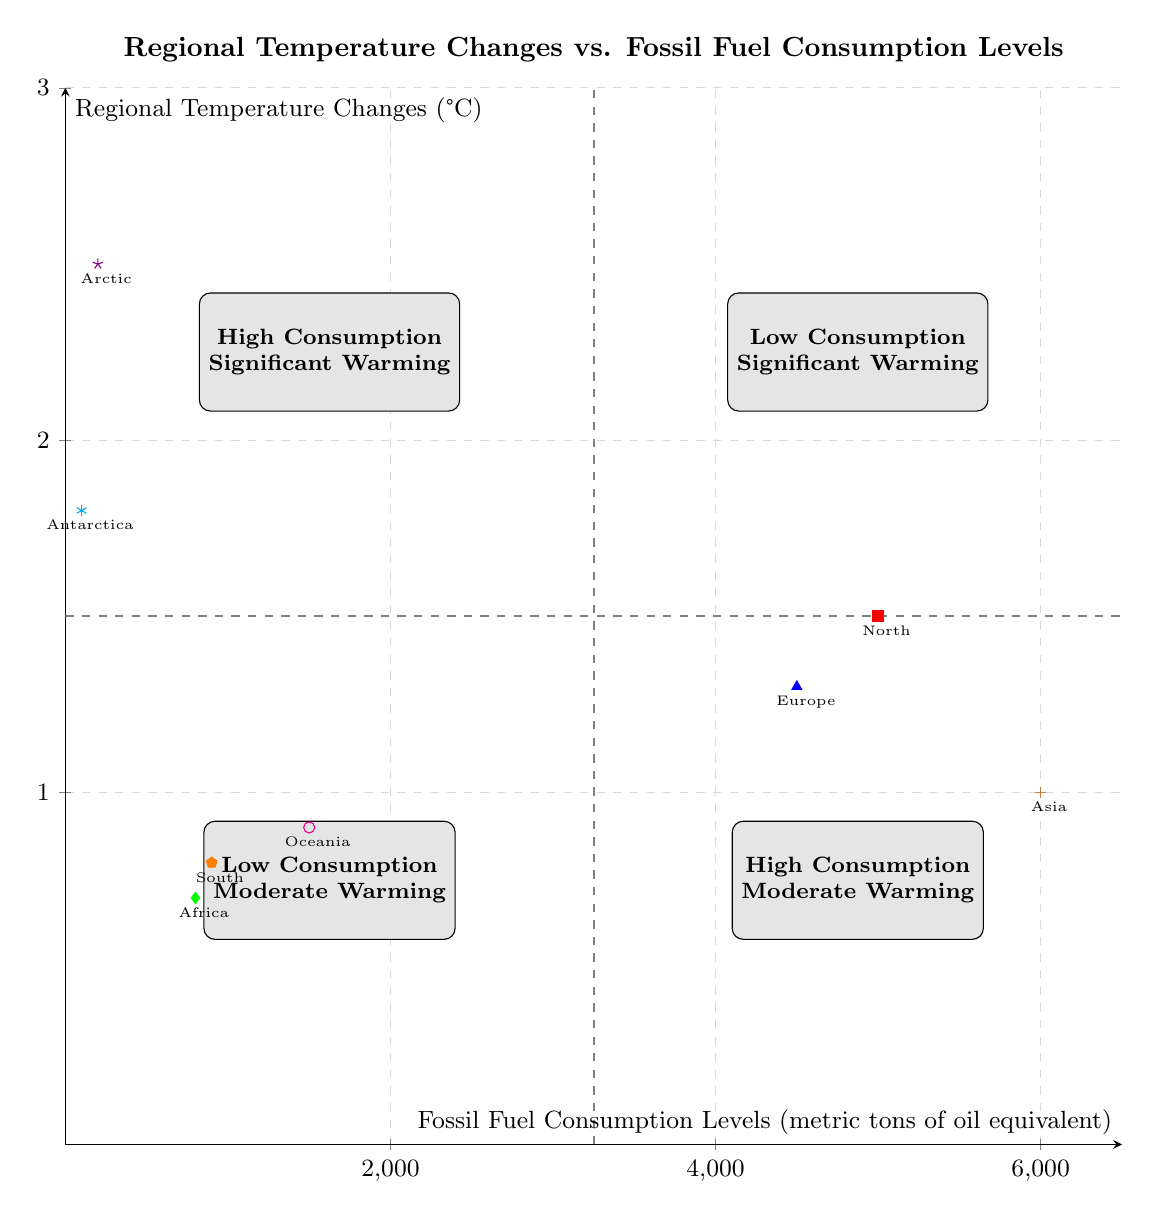What is the temperature change in North America? According to the diagram, North America is located in the "High Consumption - Significant Warming" quadrant, and its corresponding temperature change is 1.5 degrees Celsius.
Answer: 1.5 degrees Celsius Which region shows the highest temperature change among those with low fossil fuel consumption? In the "Low Consumption - Significant Warming" quadrant, the Arctic shows the highest temperature change of 2.5 degrees Celsius. Thus, it has the greatest temperature change among regions with low fossil fuel consumption.
Answer: 2.5 degrees Celsius How many regions are categorized as having high fossil fuel consumption and moderate warming? The "High Consumption - Moderate Warming" quadrant includes two regions: Asia and Oceania. Therefore, the number of regions in this category is two.
Answer: Two Which region has the lowest fossil fuel consumption? By examining the diagram, Antarctica is shown to have the lowest fossil fuel consumption level at 100 metric tons of oil equivalent.
Answer: 100 metric tons of oil equivalent Is there a correlation between fossil fuel consumption and temperature change for regions in the "High Consumption - Significant Warming" quadrant? Yes, both North America and Europe show high fossil fuel consumption levels (5000 and 4500 respectively) and also relatively high temperature changes (1.5 and 1.3 degrees Celsius respectively). This indicates a correlation where higher fossil fuel consumption is associated with greater warming.
Answer: Yes What fossil fuel consumption level corresponds to significant warming in regions with low consumption? The diagram shows that the Arctic and Antarctica in the "Low Consumption - Significant Warming" quadrant have fossil fuel consumption levels of 200 and 100 metric tons of oil equivalent, respectively.
Answer: 200 and 100 metric tons of oil equivalent Which quadrant contains regions that have low fossil fuel consumption but moderate warming? The "Low Consumption - Moderate Warming" quadrant includes Africa and South America, as shown in the diagram.
Answer: Low Consumption - Moderate Warming What is the temperature change of Asia in the context of fossil fuel consumption? Asia, located in the "High Consumption - Moderate Warming" quadrant, has a temperature change of 1.0 degrees Celsius.
Answer: 1.0 degrees Celsius 